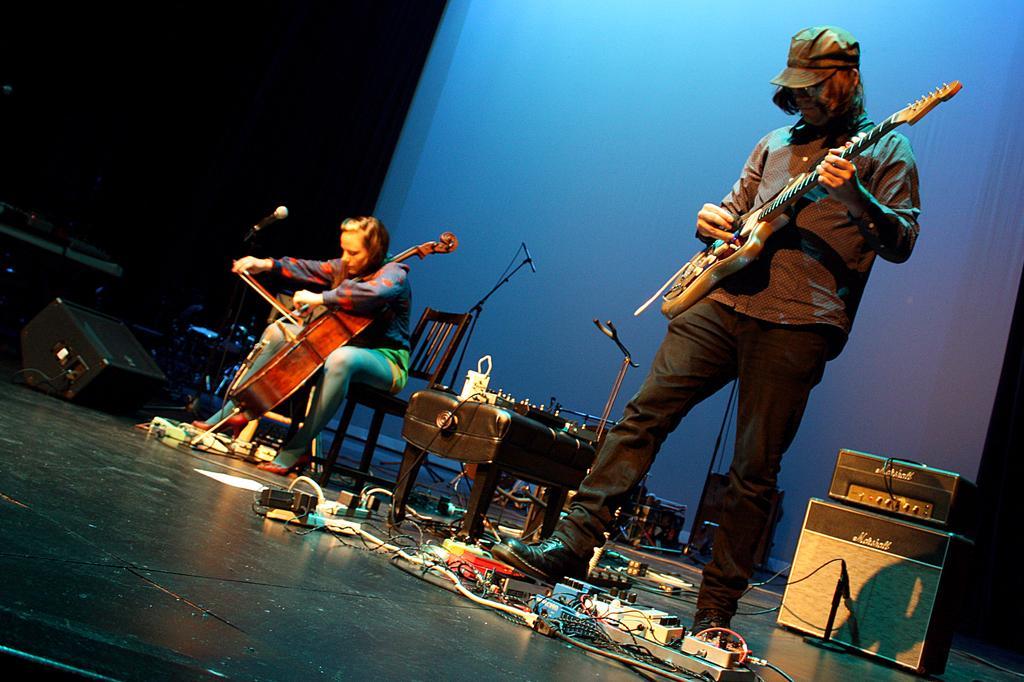Can you describe this image briefly? As we can see in a picture that one man is standing and holding a guitar and a woman is sitting and playing a piano. These are the microphones. 